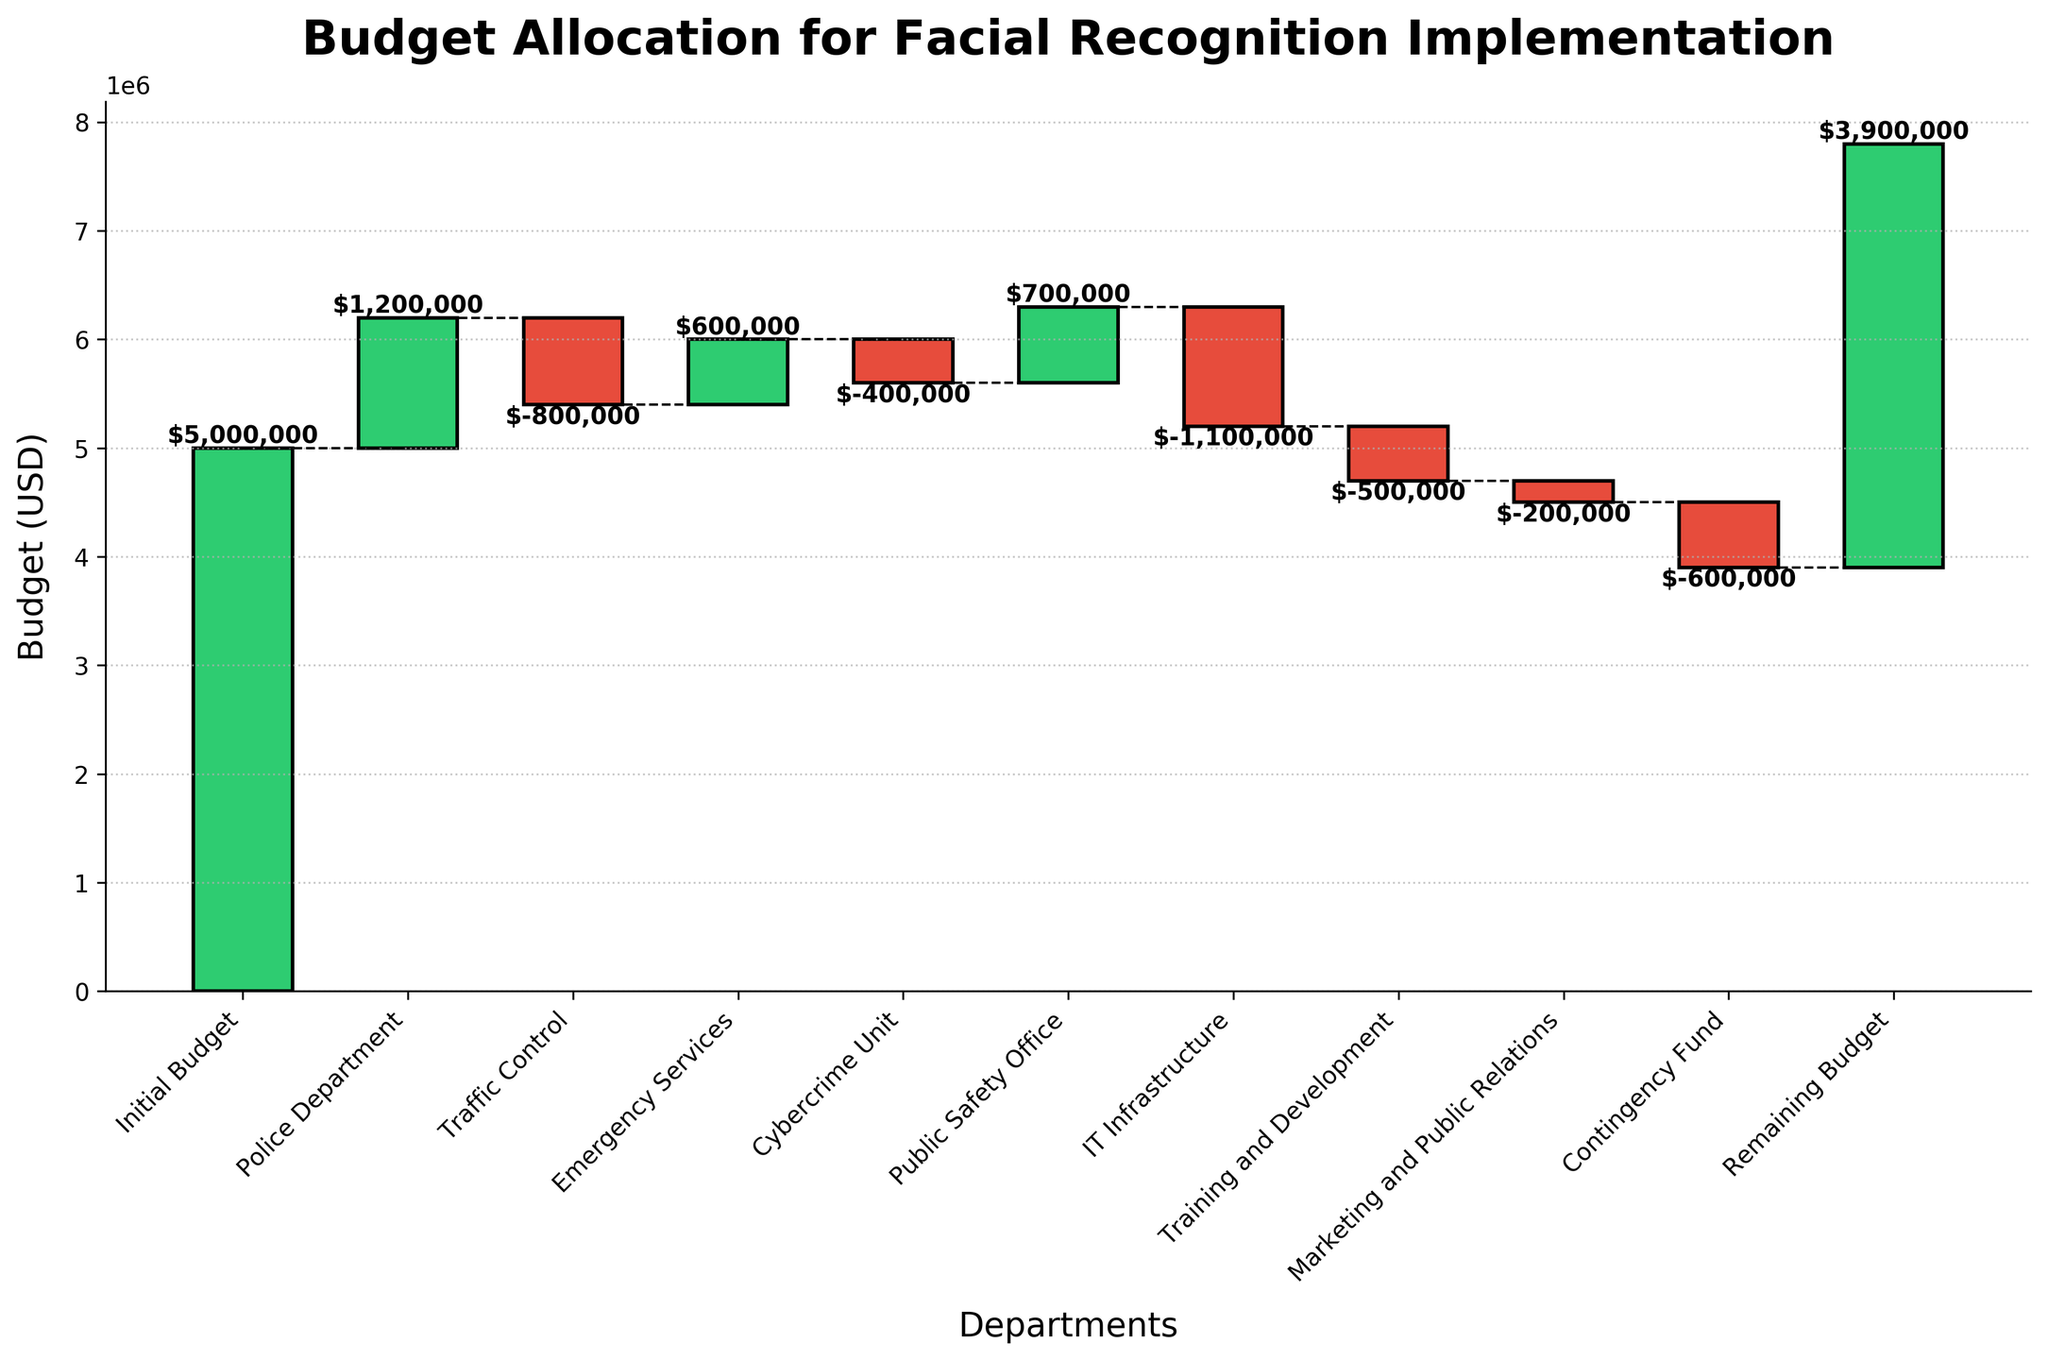What's the title of the figure? The title of the figure is displayed at the top in bold font.
Answer: Budget Allocation for Facial Recognition Implementation What are the labels on the x-axis and y-axis? The x-axis represents departments or budget categories, and the y-axis represents the budget in USD.
Answer: Departments, Budget (USD) How much budget was initially allocated? The initial budget is shown as the first bar on the left of the figure.
Answer: $5,000,000 Which category has the highest budget allocation? By visual inspection, the Police Department has the highest budget allocation, with the tallest green bar.
Answer: Police Department Which two categories have negative budget allocations? The categories with negative budget allocations are shown with red bars.
Answer: Traffic Control, IT Infrastructure What is the remaining budget after all allocations? The remaining budget after all the allocations is displayed as the last bar on the right.
Answer: $3,900,000 How much was the budget allocation for Emergency Services? The budget allocation for Emergency Services is shown as a single green bar in the figure.
Answer: $600,000 What is the net change in budget for the Cybercrime Unit? The net change in budget for the Cybercrime Unit is shown as a red bar with a negative value.
Answer: -$400,000 Which category had a higher budget allocation: Public Safety Office or Training and Development? The Public Safety Office allocation is shown as a taller green bar compared to the Training and Development allocation.
Answer: Public Safety Office What is the total budget allocated to categories with negative values? Sum the negative values: (-$800,000 for Traffic Control) + (-$400,000 for Cybercrime Unit) + (-$1,100,000 for IT Infrastructure) + (-$500,000 for Training and Development) + (-$200,000 for Marketing and Public Relations) + (-$600,000 for Contingency Fund). Total = -$3,600,000
Answer: -$3,600,000 